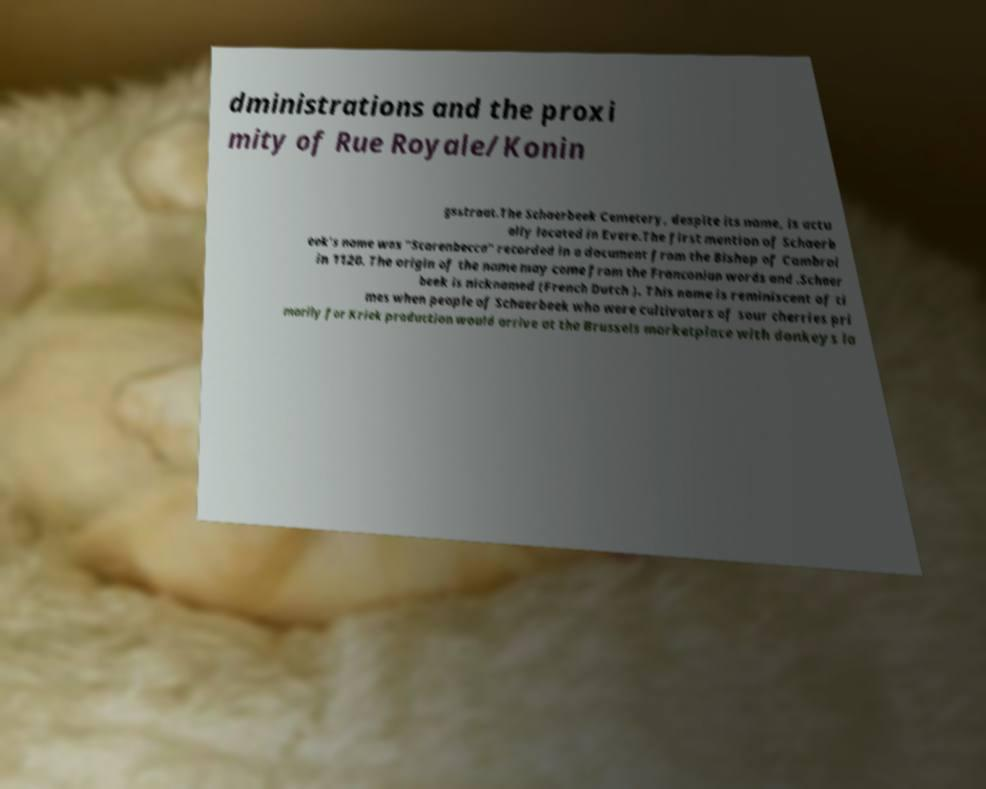Please identify and transcribe the text found in this image. dministrations and the proxi mity of Rue Royale/Konin gsstraat.The Schaerbeek Cemetery, despite its name, is actu ally located in Evere.The first mention of Schaerb eek's name was "Scarenbecca" recorded in a document from the Bishop of Cambrai in 1120. The origin of the name may come from the Franconian words and .Schaer beek is nicknamed (French Dutch ). This name is reminiscent of ti mes when people of Schaerbeek who were cultivators of sour cherries pri marily for Kriek production would arrive at the Brussels marketplace with donkeys la 